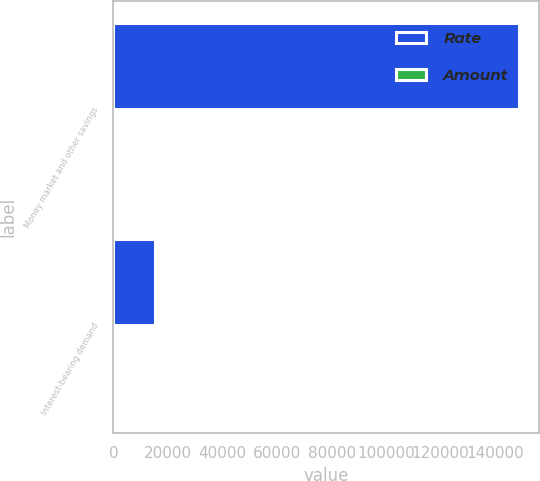Convert chart. <chart><loc_0><loc_0><loc_500><loc_500><stacked_bar_chart><ecel><fcel>Money market and other savings<fcel>Interest-bearing demand<nl><fcel>Rate<fcel>148679<fcel>15319<nl><fcel>Amount<fcel>0.09<fcel>0.14<nl></chart> 